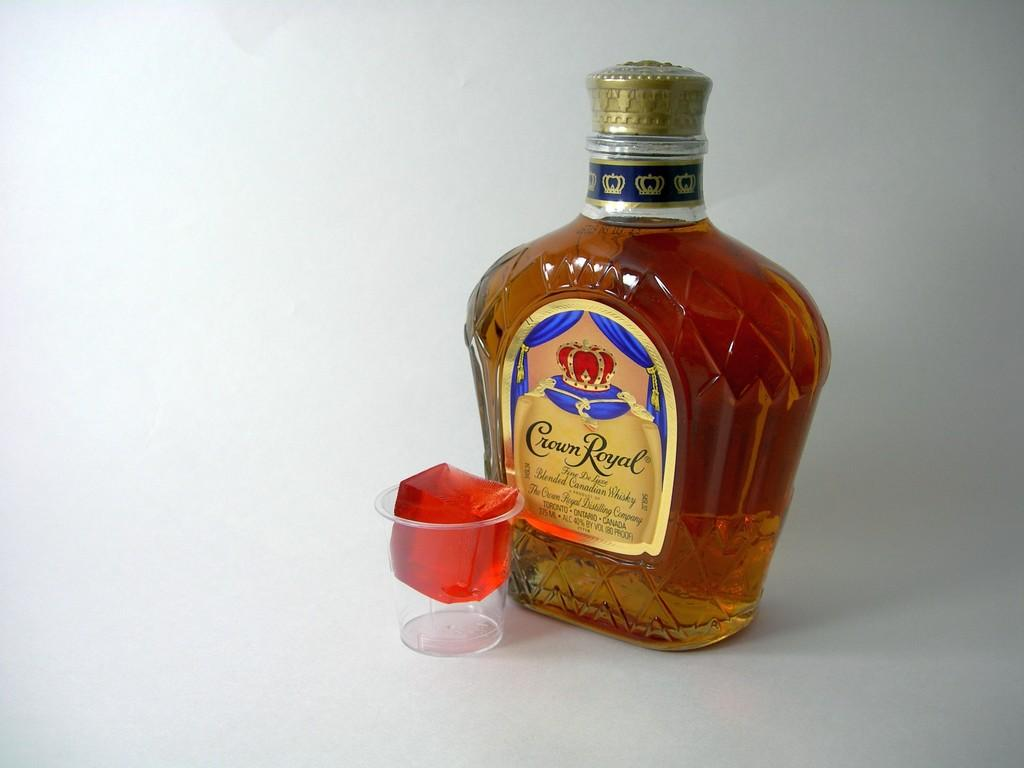<image>
Summarize the visual content of the image. A bottle of Crown Royal whiskey next to a small plastic cup containing a red cube of gelatin. 